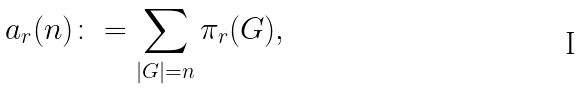<formula> <loc_0><loc_0><loc_500><loc_500>a _ { r } ( n ) \colon = \sum _ { | G | = n } \pi _ { r } ( G ) ,</formula> 